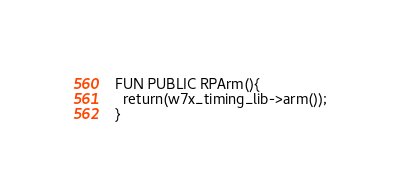<code> <loc_0><loc_0><loc_500><loc_500><_SML_>FUN PUBLIC RPArm(){
  return(w7x_timing_lib->arm());
}
</code> 